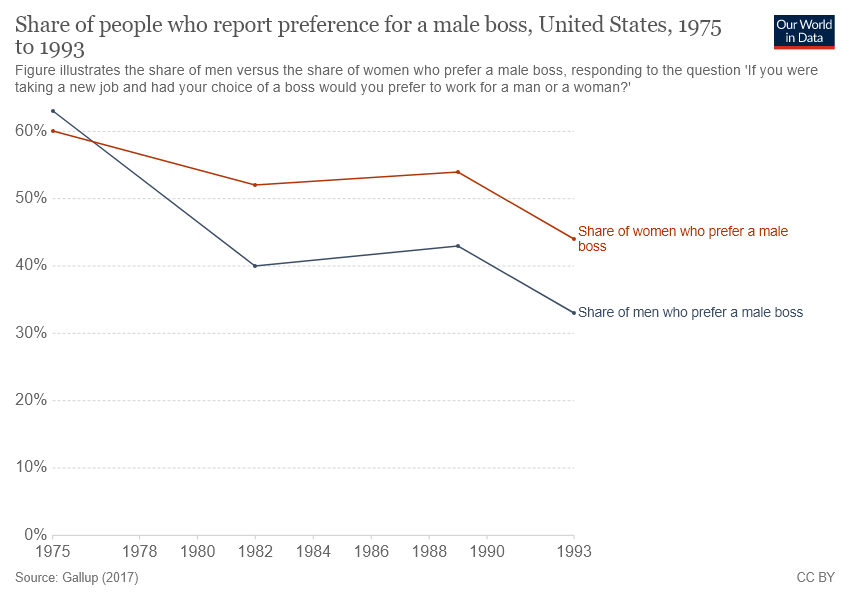Draw attention to some important aspects in this diagram. According to the given data, the percentage of men who prefer a male boss has decreased below 40% in 1993. The study found that a significant percentage of women prefer to have a male boss, with the red line representing this preference. 